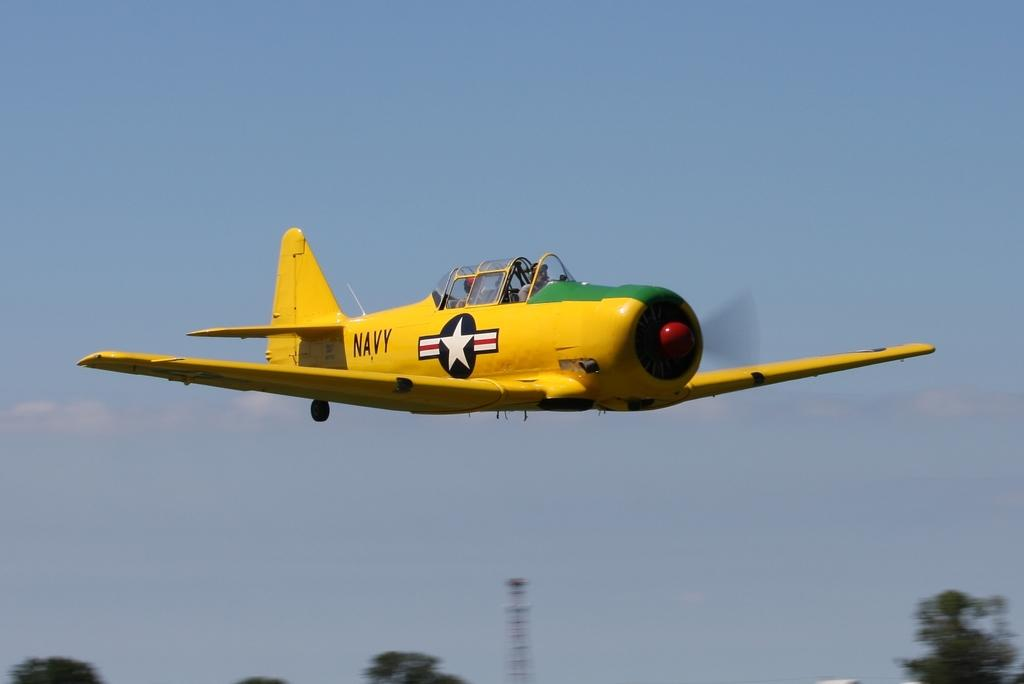<image>
Offer a succinct explanation of the picture presented. A bright yellow plane that says Navy on the side. 